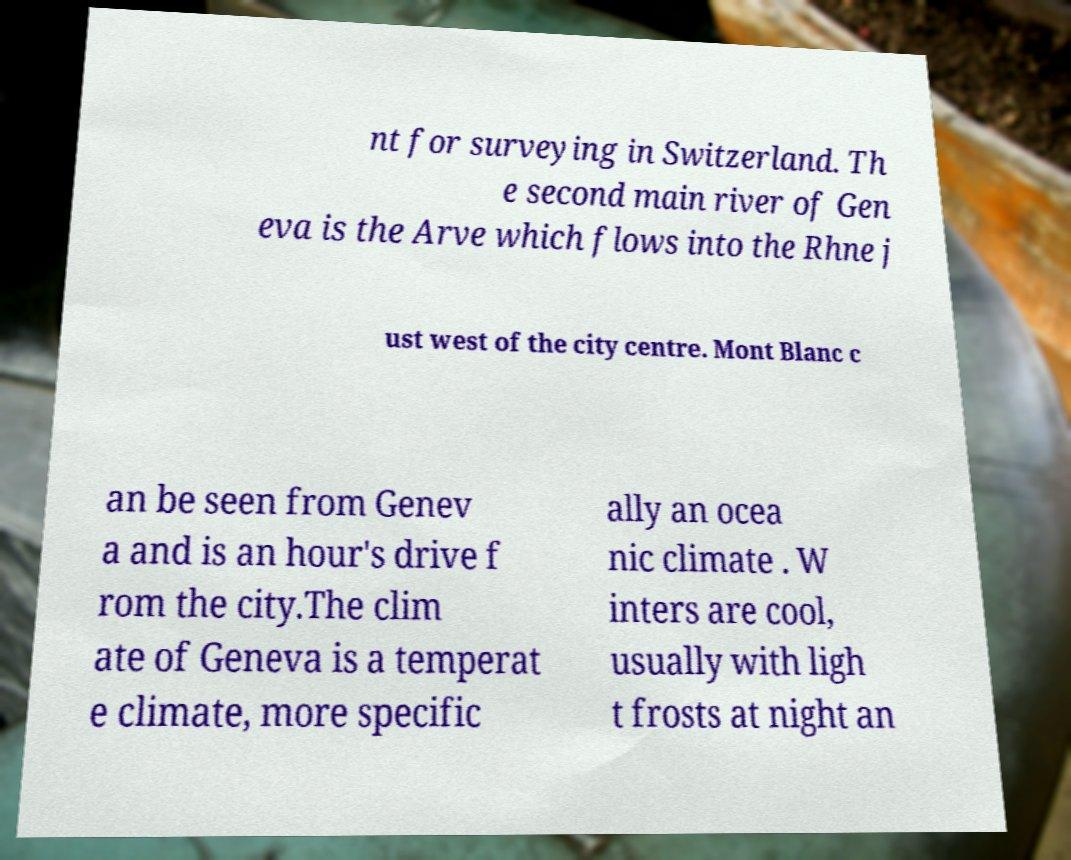Can you accurately transcribe the text from the provided image for me? nt for surveying in Switzerland. Th e second main river of Gen eva is the Arve which flows into the Rhne j ust west of the city centre. Mont Blanc c an be seen from Genev a and is an hour's drive f rom the city.The clim ate of Geneva is a temperat e climate, more specific ally an ocea nic climate . W inters are cool, usually with ligh t frosts at night an 